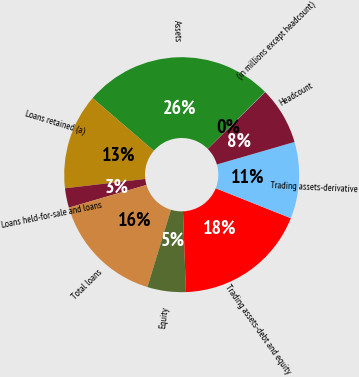Convert chart. <chart><loc_0><loc_0><loc_500><loc_500><pie_chart><fcel>(in millions except headcount)<fcel>Assets<fcel>Loans retained (a)<fcel>Loans held-for-sale and loans<fcel>Total loans<fcel>Equity<fcel>Trading assets-debt and equity<fcel>Trading assets-derivative<fcel>Headcount<nl><fcel>0.06%<fcel>26.23%<fcel>13.15%<fcel>2.68%<fcel>15.76%<fcel>5.29%<fcel>18.38%<fcel>10.53%<fcel>7.91%<nl></chart> 